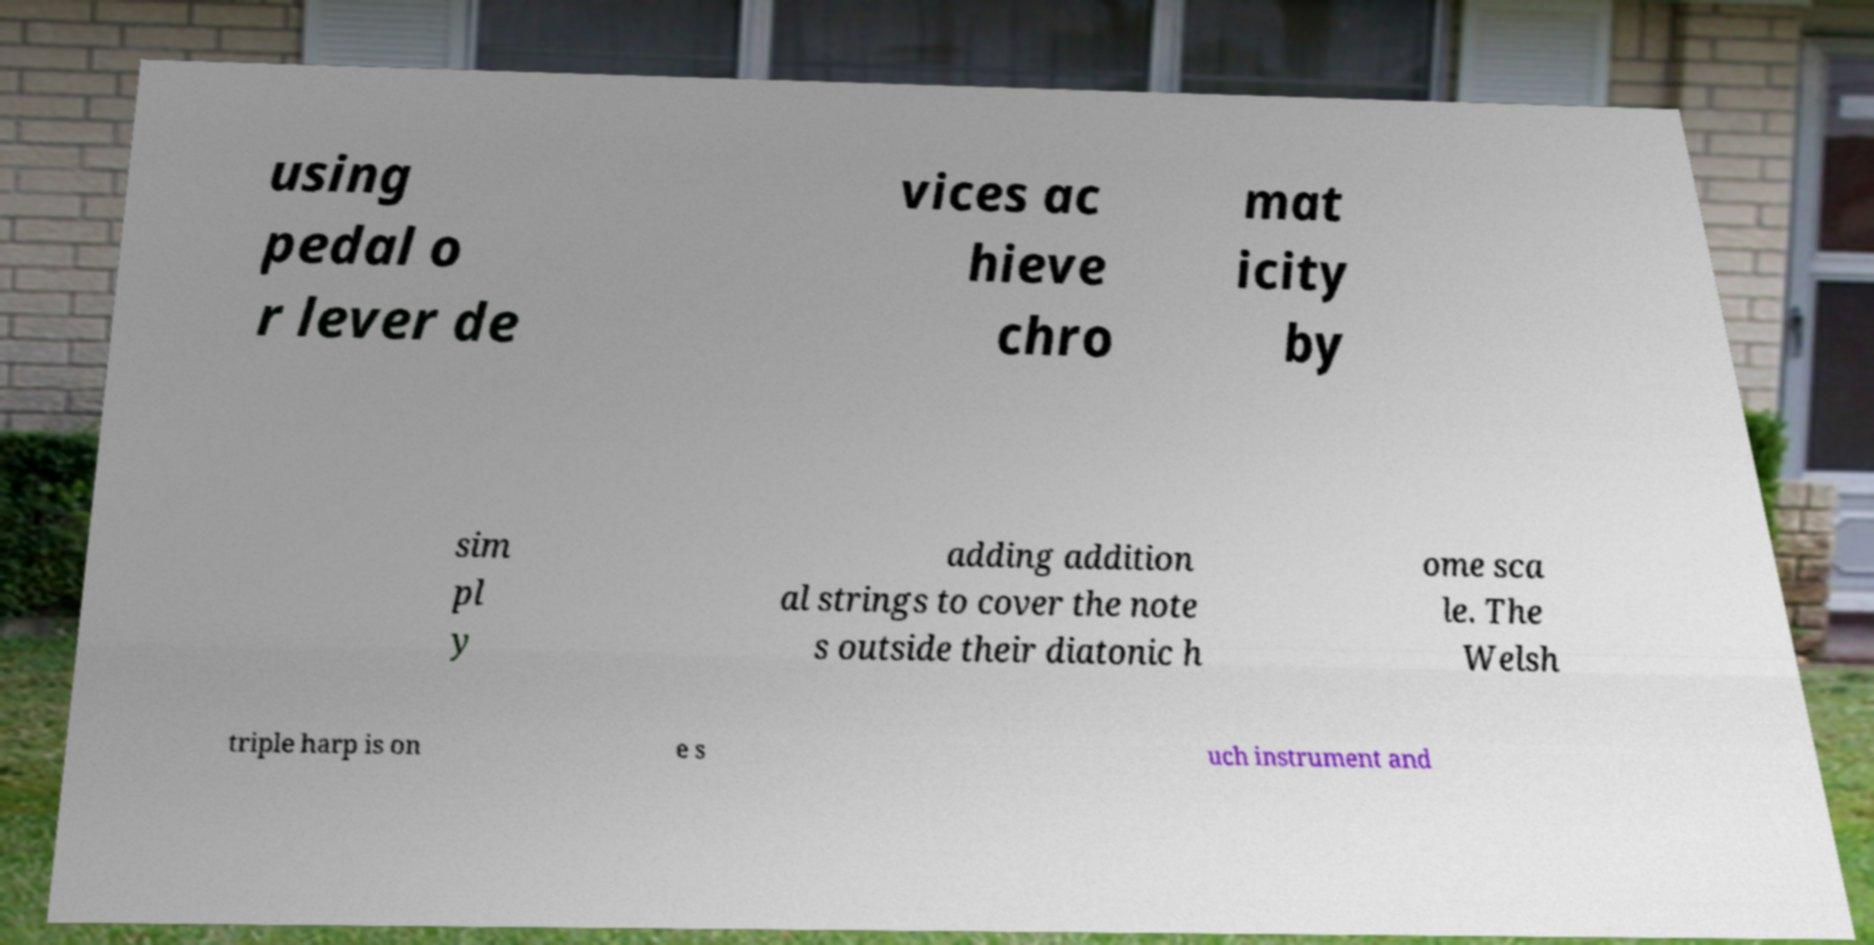For documentation purposes, I need the text within this image transcribed. Could you provide that? using pedal o r lever de vices ac hieve chro mat icity by sim pl y adding addition al strings to cover the note s outside their diatonic h ome sca le. The Welsh triple harp is on e s uch instrument and 